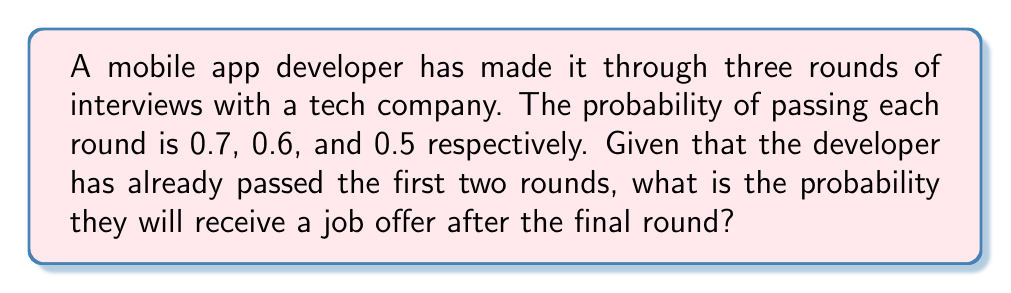Show me your answer to this math problem. Let's approach this step-by-step:

1) First, we need to understand what the question is asking. We're looking for the probability of passing the third round, given that the first two rounds have already been passed.

2) This is a conditional probability problem. We're not concerned with the probabilities of the first two rounds anymore, as we know they've been passed.

3) The probability of passing the third round is given as 0.5.

4) In probability theory, when events are independent (as interview rounds typically are), the probability of the final event occurring, given that previous events have occurred, is simply the probability of that final event.

5) Therefore, the probability of receiving a job offer (passing the third round) given that the first two rounds were passed is:

   $P(\text{job offer} | \text{passed rounds 1 and 2}) = P(\text{passing round 3}) = 0.5$

6) We can express this mathematically as:

   $$P(A|B) = P(A) = 0.5$$

   Where $A$ is the event of passing the third round (receiving a job offer), and $B$ is the event of having passed the first two rounds.
Answer: 0.5 